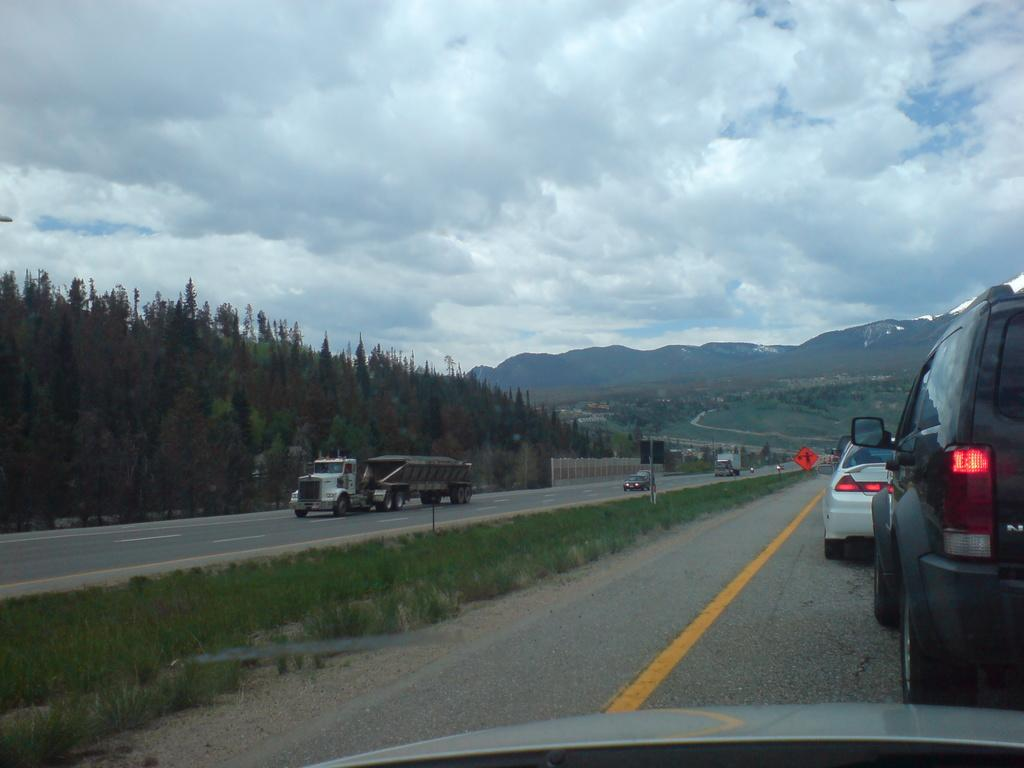What is happening on the road in the image? There are vehicles moving on the road in the image. What can be seen in the background of the image? There are trees, mountains, and the sky visible in the background of the image. What type of pencil is being used to draw the mountains in the image? There is no pencil or drawing activity present in the image; it is a photograph of a real scene. Who needs to approve the trees in the image? There is no approval process required for the trees in the image; they are a natural part of the landscape. 